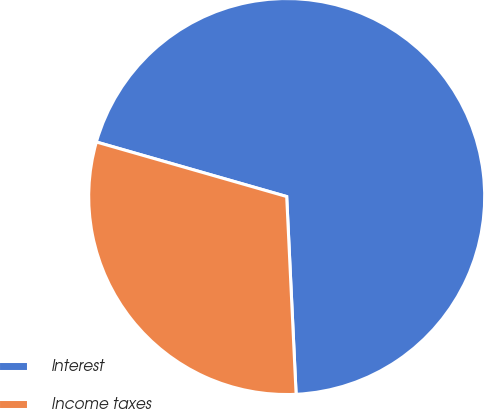Convert chart to OTSL. <chart><loc_0><loc_0><loc_500><loc_500><pie_chart><fcel>Interest<fcel>Income taxes<nl><fcel>69.8%<fcel>30.2%<nl></chart> 